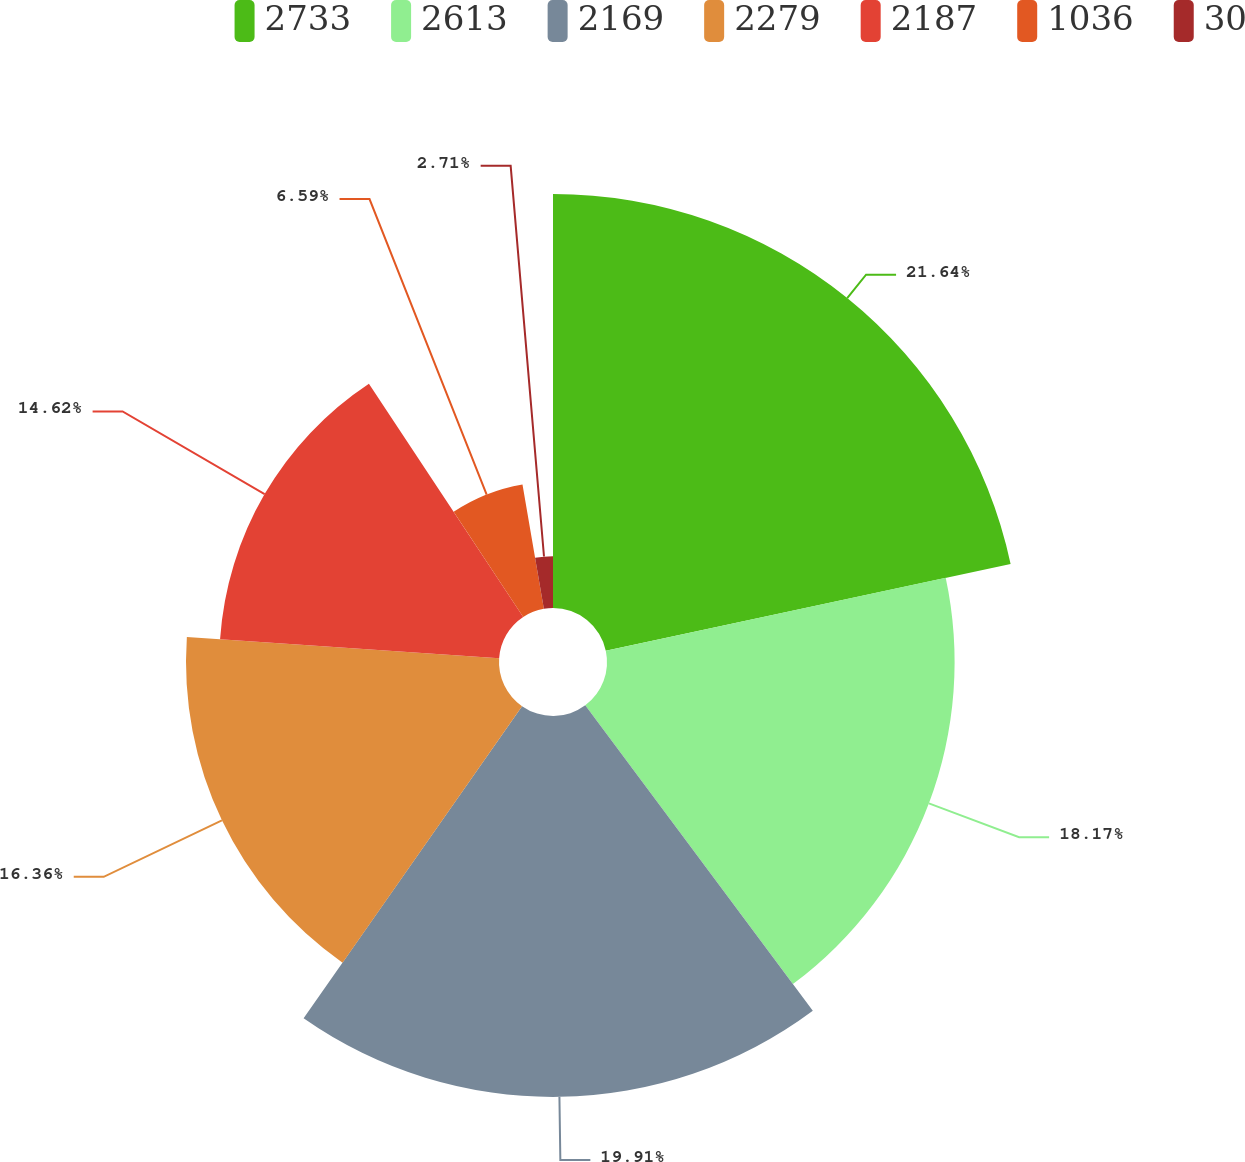<chart> <loc_0><loc_0><loc_500><loc_500><pie_chart><fcel>2733<fcel>2613<fcel>2169<fcel>2279<fcel>2187<fcel>1036<fcel>30<nl><fcel>21.64%<fcel>18.17%<fcel>19.91%<fcel>16.36%<fcel>14.62%<fcel>6.59%<fcel>2.71%<nl></chart> 